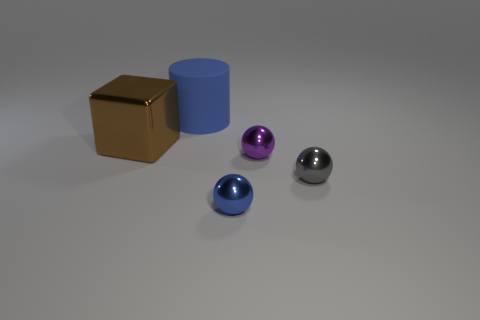Subtract all gray balls. How many balls are left? 2 Subtract 1 cylinders. How many cylinders are left? 0 Subtract all blocks. How many objects are left? 4 Subtract all purple cubes. Subtract all blue cylinders. How many cubes are left? 1 Subtract all green cylinders. How many blue balls are left? 1 Subtract all purple balls. Subtract all tiny blue things. How many objects are left? 3 Add 5 small blue metal things. How many small blue metal things are left? 6 Add 3 tiny yellow matte cylinders. How many tiny yellow matte cylinders exist? 3 Add 3 metallic things. How many objects exist? 8 Subtract 1 brown blocks. How many objects are left? 4 